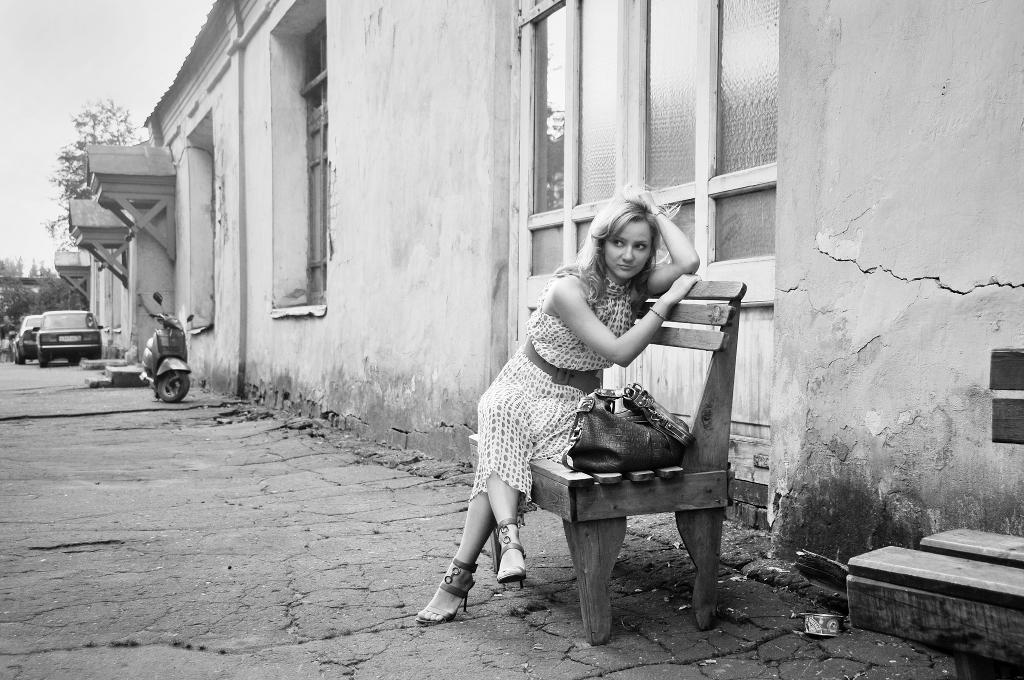What is the woman doing in the image? The woman is sitting on a bench in the image. What is on the bench with the woman? There is a bag on the bench. What can be seen in the distance behind the woman? There is a building with visible windows in the background, and there are vehicles on a path in the background. What type of milk is the woman drinking in the image? There is no milk present in the image, and the woman is not shown drinking anything. 